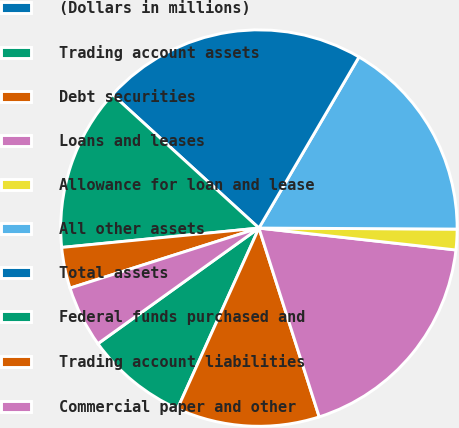<chart> <loc_0><loc_0><loc_500><loc_500><pie_chart><fcel>(Dollars in millions)<fcel>Trading account assets<fcel>Debt securities<fcel>Loans and leases<fcel>Allowance for loan and lease<fcel>All other assets<fcel>Total assets<fcel>Federal funds purchased and<fcel>Trading account liabilities<fcel>Commercial paper and other<nl><fcel>0.01%<fcel>8.34%<fcel>11.66%<fcel>18.32%<fcel>1.68%<fcel>16.66%<fcel>21.65%<fcel>13.33%<fcel>3.34%<fcel>5.01%<nl></chart> 